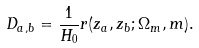<formula> <loc_0><loc_0><loc_500><loc_500>D _ { a , b } = \frac { 1 } { H _ { 0 } } r ( z _ { a } , z _ { b } ; \Omega _ { m } , m ) .</formula> 